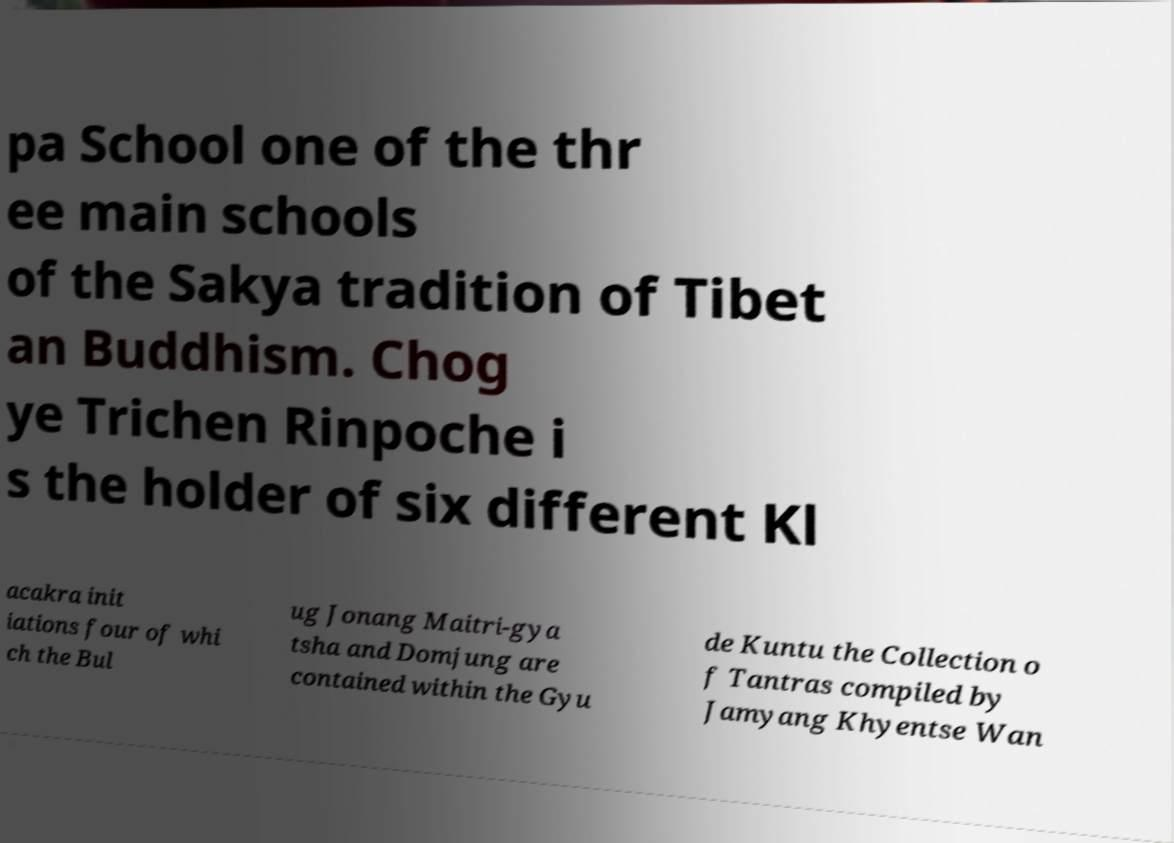What messages or text are displayed in this image? I need them in a readable, typed format. pa School one of the thr ee main schools of the Sakya tradition of Tibet an Buddhism. Chog ye Trichen Rinpoche i s the holder of six different Kl acakra init iations four of whi ch the Bul ug Jonang Maitri-gya tsha and Domjung are contained within the Gyu de Kuntu the Collection o f Tantras compiled by Jamyang Khyentse Wan 